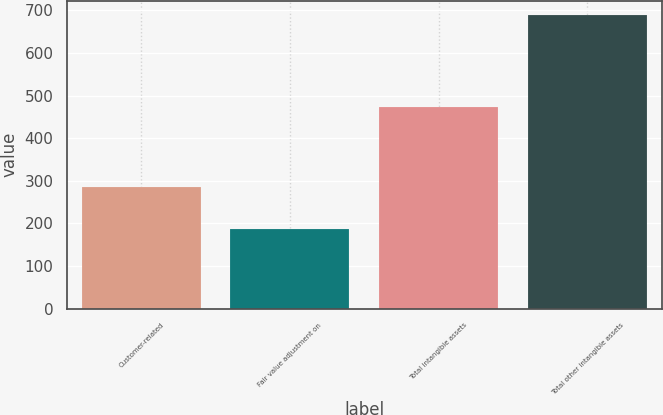<chart> <loc_0><loc_0><loc_500><loc_500><bar_chart><fcel>Customer-related<fcel>Fair value adjustment on<fcel>Total intangible assets<fcel>Total other intangible assets<nl><fcel>285<fcel>187<fcel>472<fcel>688<nl></chart> 